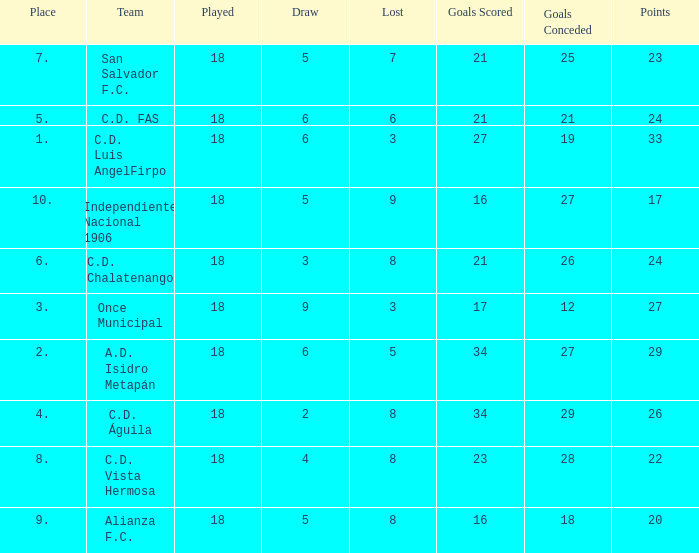What were the goal conceded that had a lost greater than 8 and more than 17 points? None. 